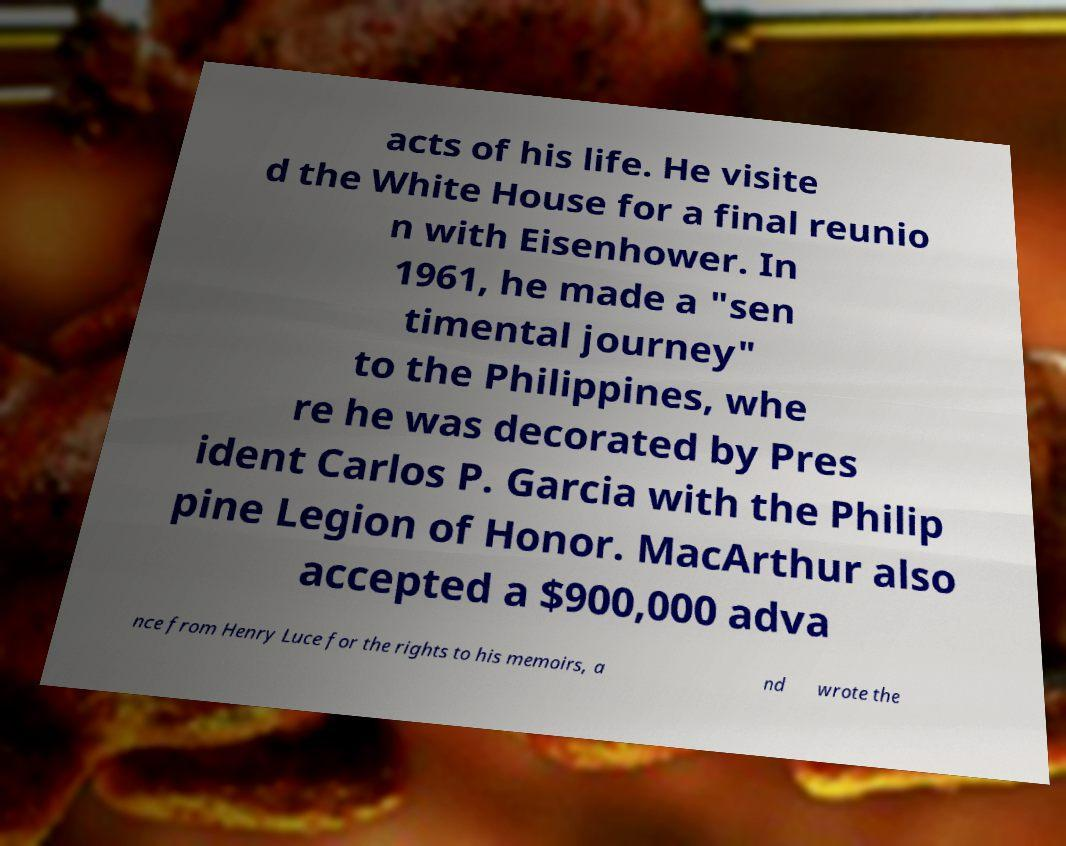What messages or text are displayed in this image? I need them in a readable, typed format. acts of his life. He visite d the White House for a final reunio n with Eisenhower. In 1961, he made a "sen timental journey" to the Philippines, whe re he was decorated by Pres ident Carlos P. Garcia with the Philip pine Legion of Honor. MacArthur also accepted a $900,000 adva nce from Henry Luce for the rights to his memoirs, a nd wrote the 